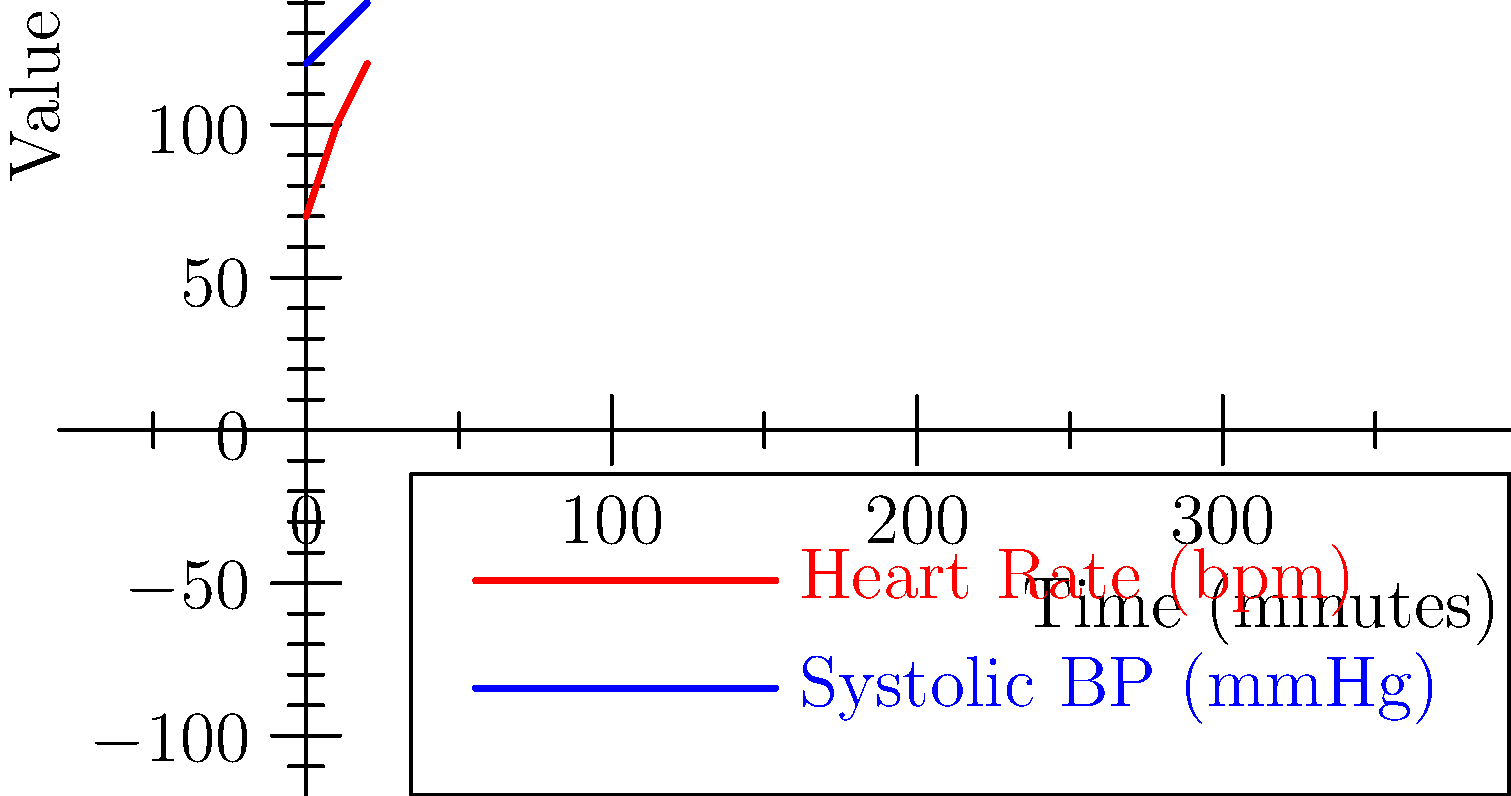Based on the simplified chart showing heart rate and systolic blood pressure over time, what could be a potential cause for the observed trends, and what immediate action should be considered? To interpret the vital signs and determine a potential cause and action:

1. Analyze the heart rate trend:
   - Heart rate increases from 70 bpm to 120 bpm over 20 minutes
   - This indicates tachycardia (HR > 100 bpm) developing

2. Analyze the systolic blood pressure trend:
   - Systolic BP increases from 120 mmHg to 140 mmHg
   - This shows a moderate increase in blood pressure

3. Combine the observations:
   - Both heart rate and blood pressure are rising simultaneously
   - This pattern suggests a stress response or compensatory mechanism

4. Consider potential causes:
   - Pain, anxiety, or fear
   - Blood loss or early stages of hypovolemic shock
   - Fever or infection

5. Determine immediate action:
   - Assess the patient for signs of bleeding or infection
   - Check temperature and other vital signs
   - Prepare for potential fluid resuscitation
   - Administer pain relief if indicated
   - Provide reassurance to reduce anxiety

Given the rapid increase in heart rate and moderate rise in blood pressure, the most likely cause is an acute stress response, possibly due to pain or anxiety. The immediate action should be to assess the patient thoroughly and address the underlying cause of stress.
Answer: Acute stress response; assess patient and address underlying cause 